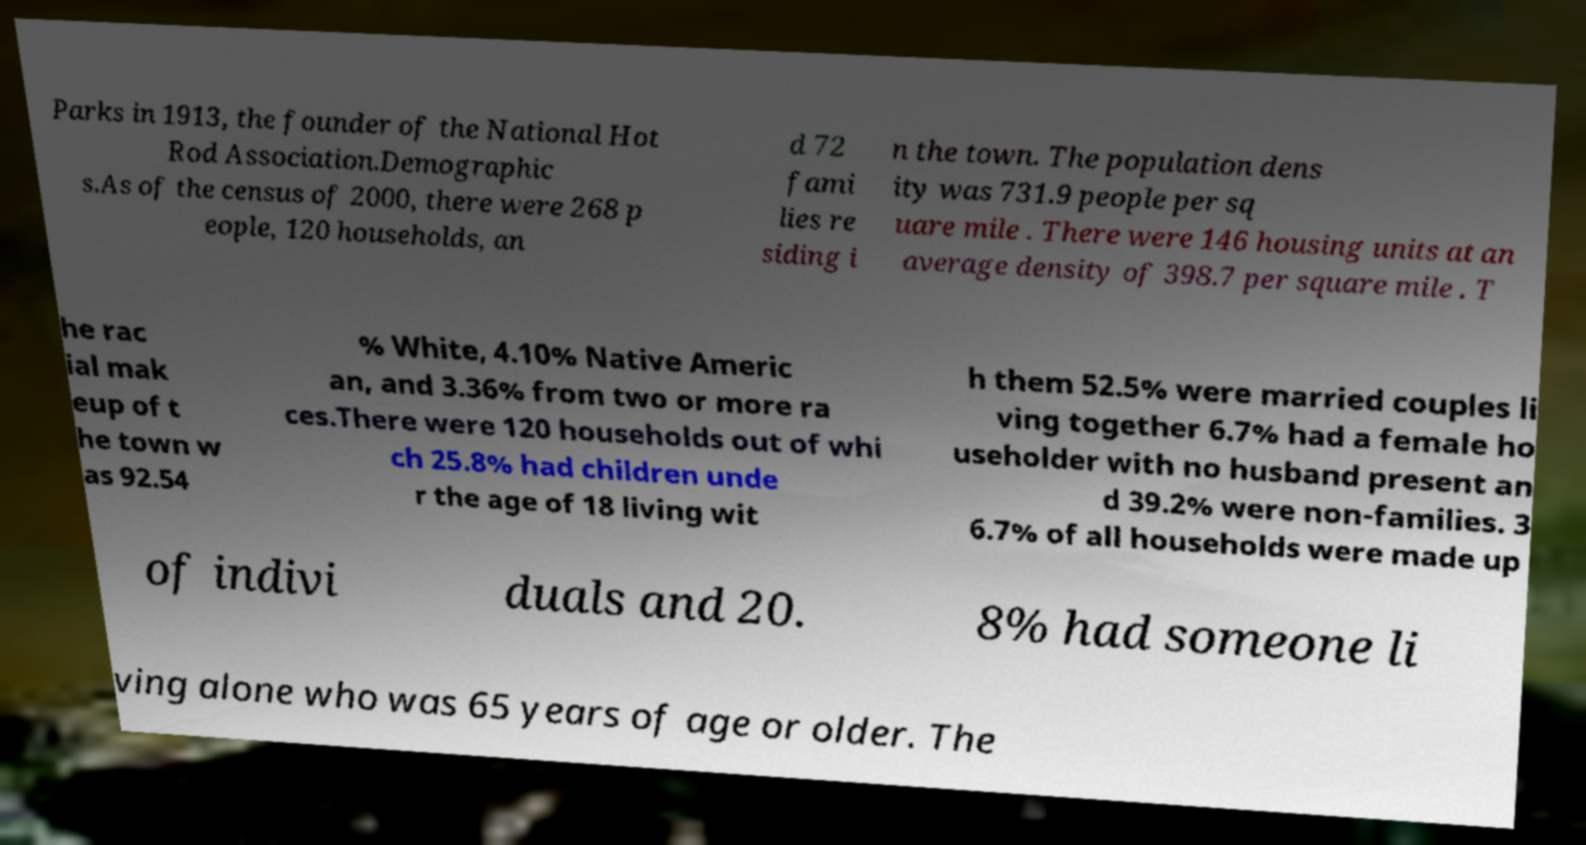Can you read and provide the text displayed in the image?This photo seems to have some interesting text. Can you extract and type it out for me? Parks in 1913, the founder of the National Hot Rod Association.Demographic s.As of the census of 2000, there were 268 p eople, 120 households, an d 72 fami lies re siding i n the town. The population dens ity was 731.9 people per sq uare mile . There were 146 housing units at an average density of 398.7 per square mile . T he rac ial mak eup of t he town w as 92.54 % White, 4.10% Native Americ an, and 3.36% from two or more ra ces.There were 120 households out of whi ch 25.8% had children unde r the age of 18 living wit h them 52.5% were married couples li ving together 6.7% had a female ho useholder with no husband present an d 39.2% were non-families. 3 6.7% of all households were made up of indivi duals and 20. 8% had someone li ving alone who was 65 years of age or older. The 